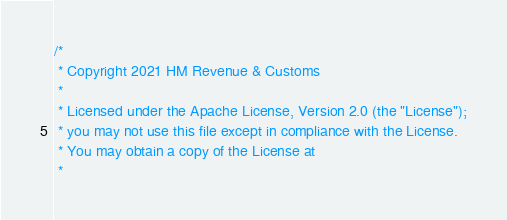<code> <loc_0><loc_0><loc_500><loc_500><_Scala_>/*
 * Copyright 2021 HM Revenue & Customs
 *
 * Licensed under the Apache License, Version 2.0 (the "License");
 * you may not use this file except in compliance with the License.
 * You may obtain a copy of the License at
 *</code> 